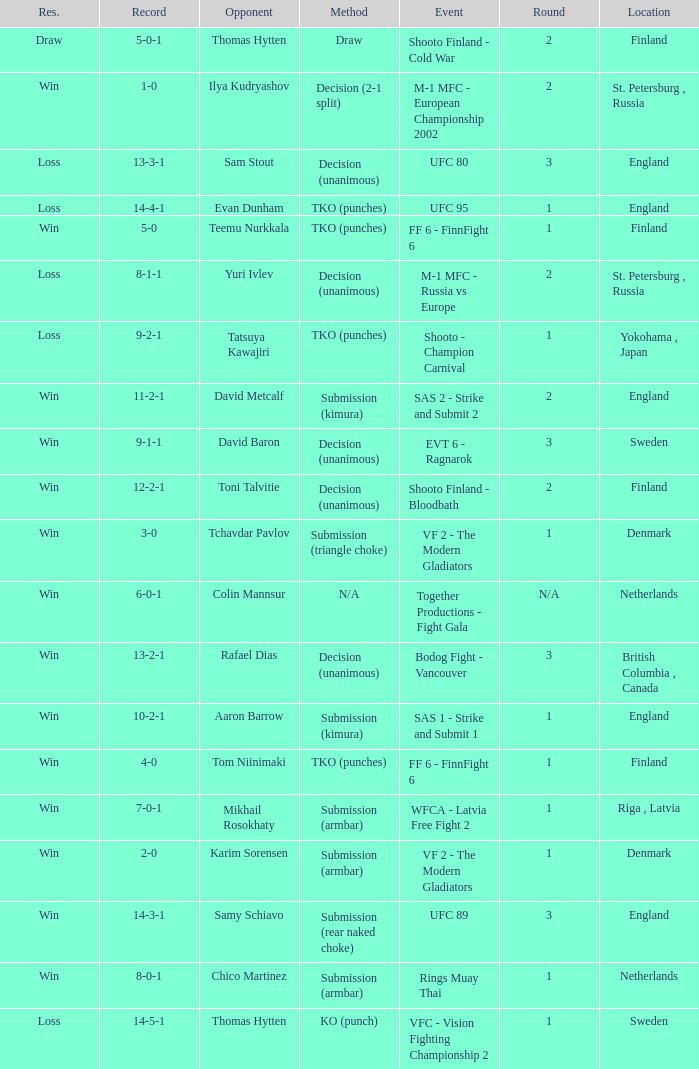What's the location when the record was 6-0-1? Netherlands. 